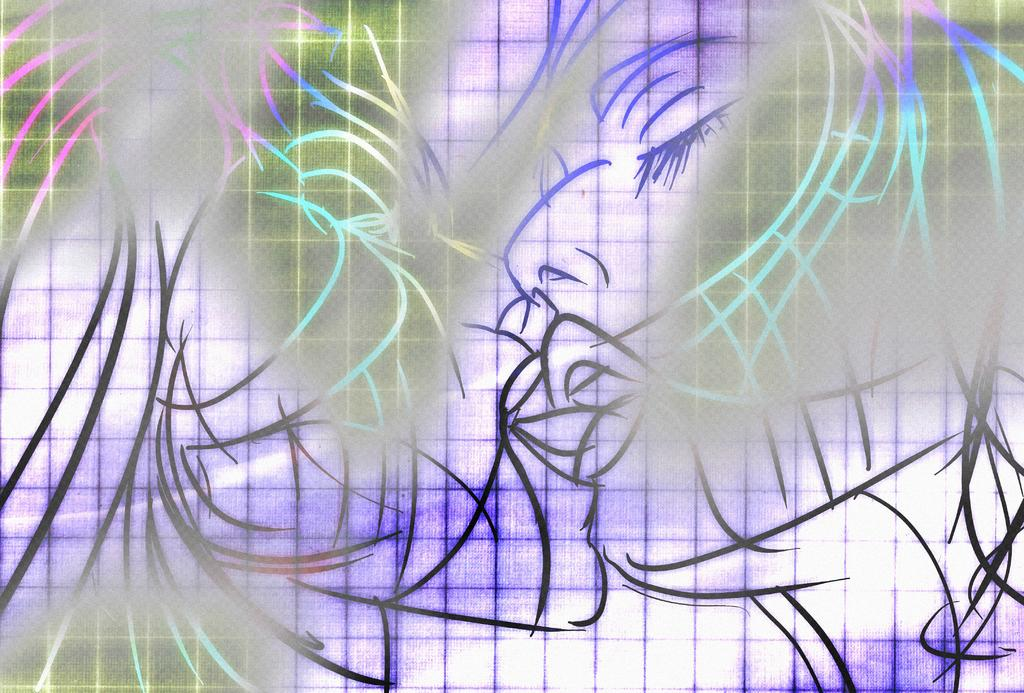What is the main subject of the image? The main subject of the image is a person. Can you describe the person in the image? The image is a graphical representation of a person, so it may not have specific details about the person's appearance or features. How many eggs are being carried by the passenger in the image? There is no passenger or eggs present in the image, as it is a graphical representation of a person. 